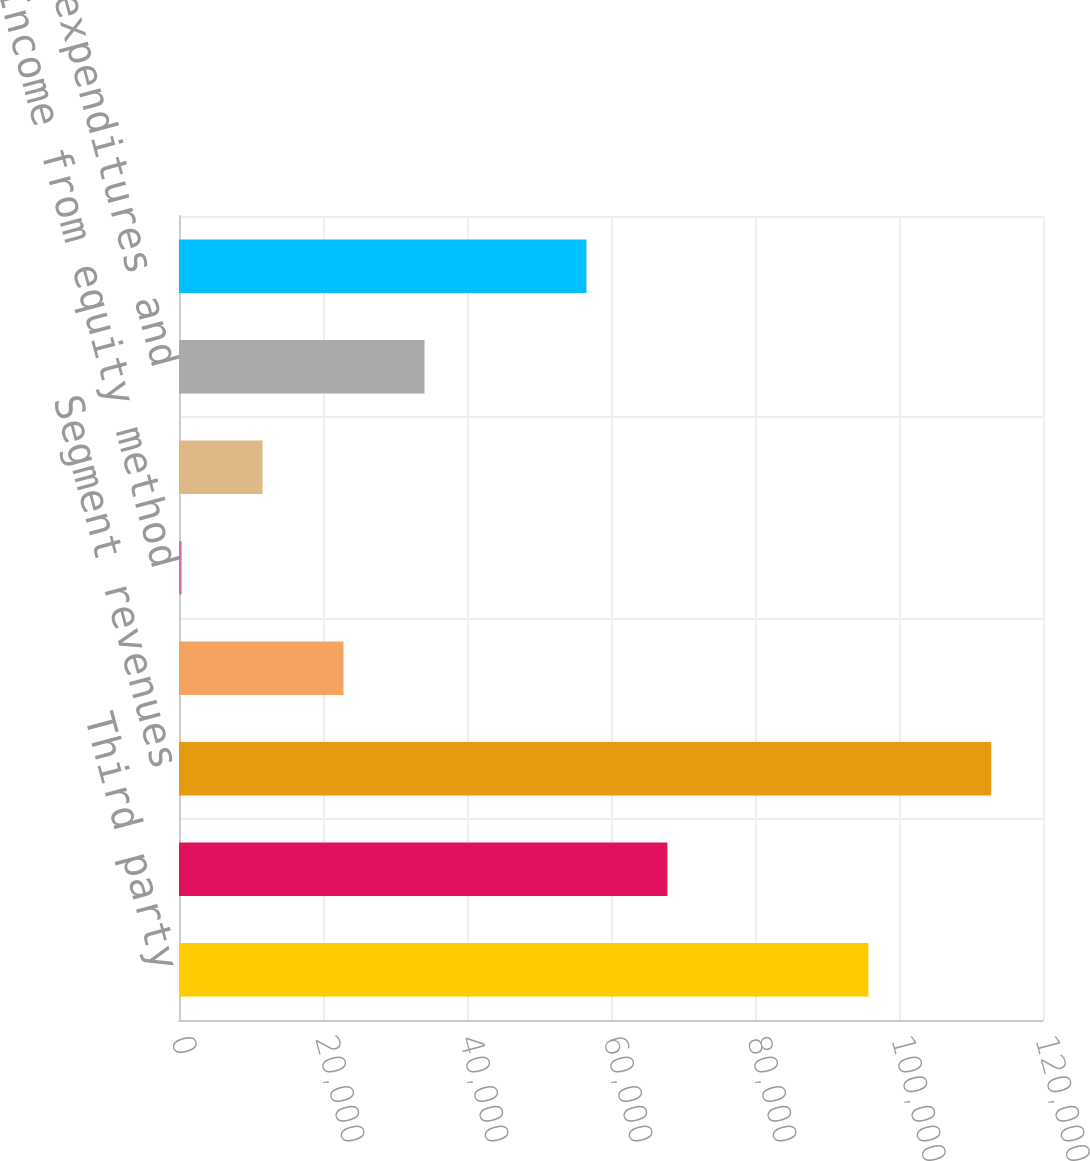Convert chart to OTSL. <chart><loc_0><loc_0><loc_500><loc_500><bar_chart><fcel>Third party<fcel>Intersegment<fcel>Segment revenues<fcel>Segment income from operations<fcel>Income from equity method<fcel>Depreciation and amortization<fcel>Capital expenditures and<fcel>Intersegment (a)<nl><fcel>95750<fcel>67831.8<fcel>112811<fcel>22852.6<fcel>363<fcel>11607.8<fcel>34097.4<fcel>56587<nl></chart> 